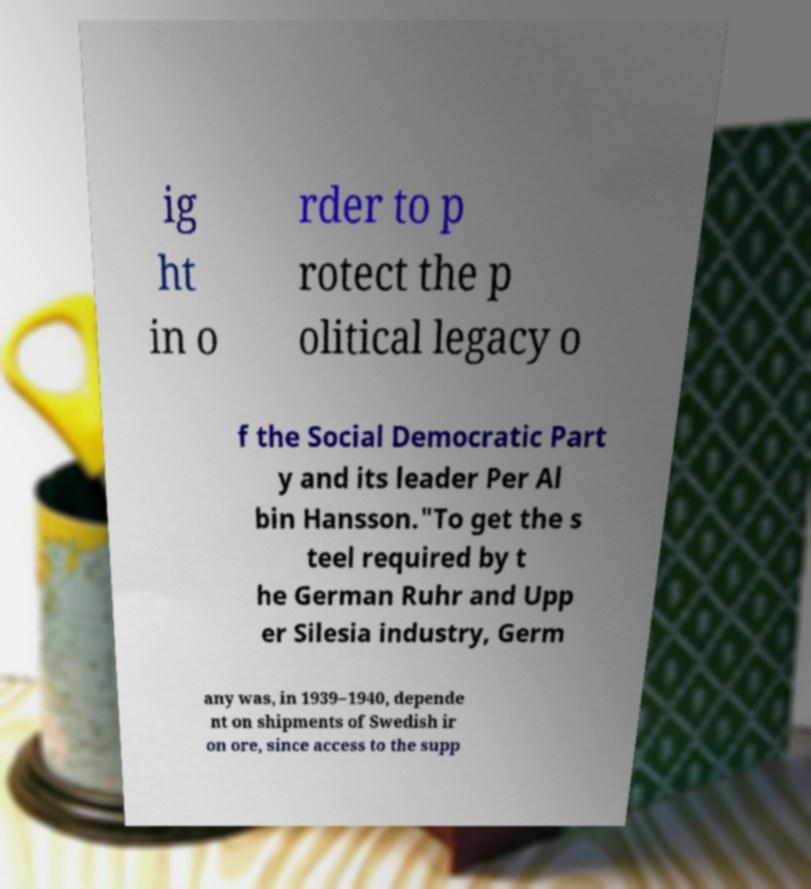Could you assist in decoding the text presented in this image and type it out clearly? ig ht in o rder to p rotect the p olitical legacy o f the Social Democratic Part y and its leader Per Al bin Hansson."To get the s teel required by t he German Ruhr and Upp er Silesia industry, Germ any was, in 1939–1940, depende nt on shipments of Swedish ir on ore, since access to the supp 